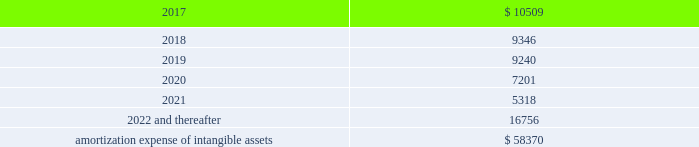Amortization expense , which is included in selling , general and administrative expenses , was $ 13.0 million , $ 13.9 million and $ 8.5 million for the years ended december 31 , 2016 , 2015 and 2014 , respectively .
The following is the estimated amortization expense for the company 2019s intangible assets as of december 31 , 2016 : ( in thousands ) .
At december 31 , 2016 , 2015 and 2014 , the company determined that its goodwill and indefinite- lived intangible assets were not impaired .
Credit facility and other long term debt credit facility the company is party to a credit agreement that provides revolving commitments for up to $ 1.25 billion of borrowings , as well as term loan commitments , in each case maturing in january 2021 .
As of december 31 , 2016 there was no outstanding balance under the revolving credit facility and $ 186.3 million of term loan borrowings remained outstanding .
At the company 2019s request and the lender 2019s consent , revolving and or term loan borrowings may be increased by up to $ 300.0 million in aggregate , subject to certain conditions as set forth in the credit agreement , as amended .
Incremental borrowings are uncommitted and the availability thereof , will depend on market conditions at the time the company seeks to incur such borrowings .
The borrowings under the revolving credit facility have maturities of less than one year .
Up to $ 50.0 million of the facility may be used for the issuance of letters of credit .
There were $ 2.6 million of letters of credit outstanding as of december 31 , 2016 .
The credit agreement contains negative covenants that , subject to significant exceptions , limit the ability of the company and its subsidiaries to , among other things , incur additional indebtedness , make restricted payments , pledge their assets as security , make investments , loans , advances , guarantees and acquisitions , undergo fundamental changes and enter into transactions with affiliates .
The company is also required to maintain a ratio of consolidated ebitda , as defined in the credit agreement , to consolidated interest expense of not less than 3.50 to 1.00 and is not permitted to allow the ratio of consolidated total indebtedness to consolidated ebitda to be greater than 3.25 to 1.00 ( 201cconsolidated leverage ratio 201d ) .
As of december 31 , 2016 , the company was in compliance with these ratios .
In addition , the credit agreement contains events of default that are customary for a facility of this nature , and includes a cross default provision whereby an event of default under other material indebtedness , as defined in the credit agreement , will be considered an event of default under the credit agreement .
Borrowings under the credit agreement bear interest at a rate per annum equal to , at the company 2019s option , either ( a ) an alternate base rate , or ( b ) a rate based on the rates applicable for deposits in the interbank market for u.s .
Dollars or the applicable currency in which the loans are made ( 201cadjusted libor 201d ) , plus in each case an applicable margin .
The applicable margin for loans will .
What is the percentage change in interest expense from 2015 to 2016? 
Computations: ((13.0 - 13.9) / 13.9)
Answer: -0.06475. 